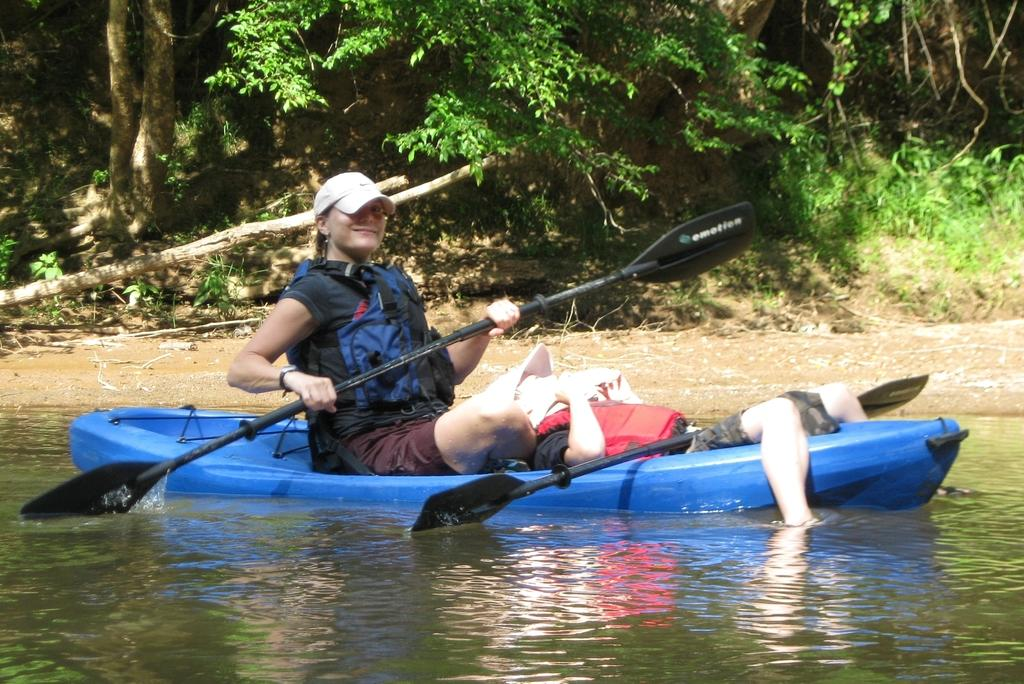What is the lady in the image doing? The lady is rowing a boat in the image. Where is the boat located? The boat is on a lake. Is there anyone else in the boat? Yes, there is a man sleeping in the boat. What can be seen in the background of the image? There are trees in the background of the image. What type of harmony is being played by the trees in the background? The trees in the background are not playing any harmony; they are simply part of the scenery. 